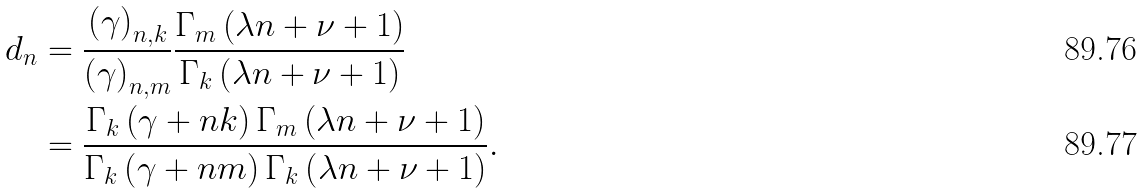<formula> <loc_0><loc_0><loc_500><loc_500>d _ { n } & = \frac { \left ( \gamma \right ) _ { n , k } } { \left ( \gamma \right ) _ { n , m } } \frac { \Gamma _ { m } \left ( \lambda n + \nu + 1 \right ) } { \Gamma _ { k } \left ( \lambda n + \nu + 1 \right ) } \\ & = \frac { \Gamma _ { k } \left ( \gamma + n k \right ) \Gamma _ { m } \left ( \lambda n + \nu + 1 \right ) } { \Gamma _ { k } \left ( \gamma + n m \right ) \Gamma _ { k } \left ( \lambda n + \nu + 1 \right ) } .</formula> 